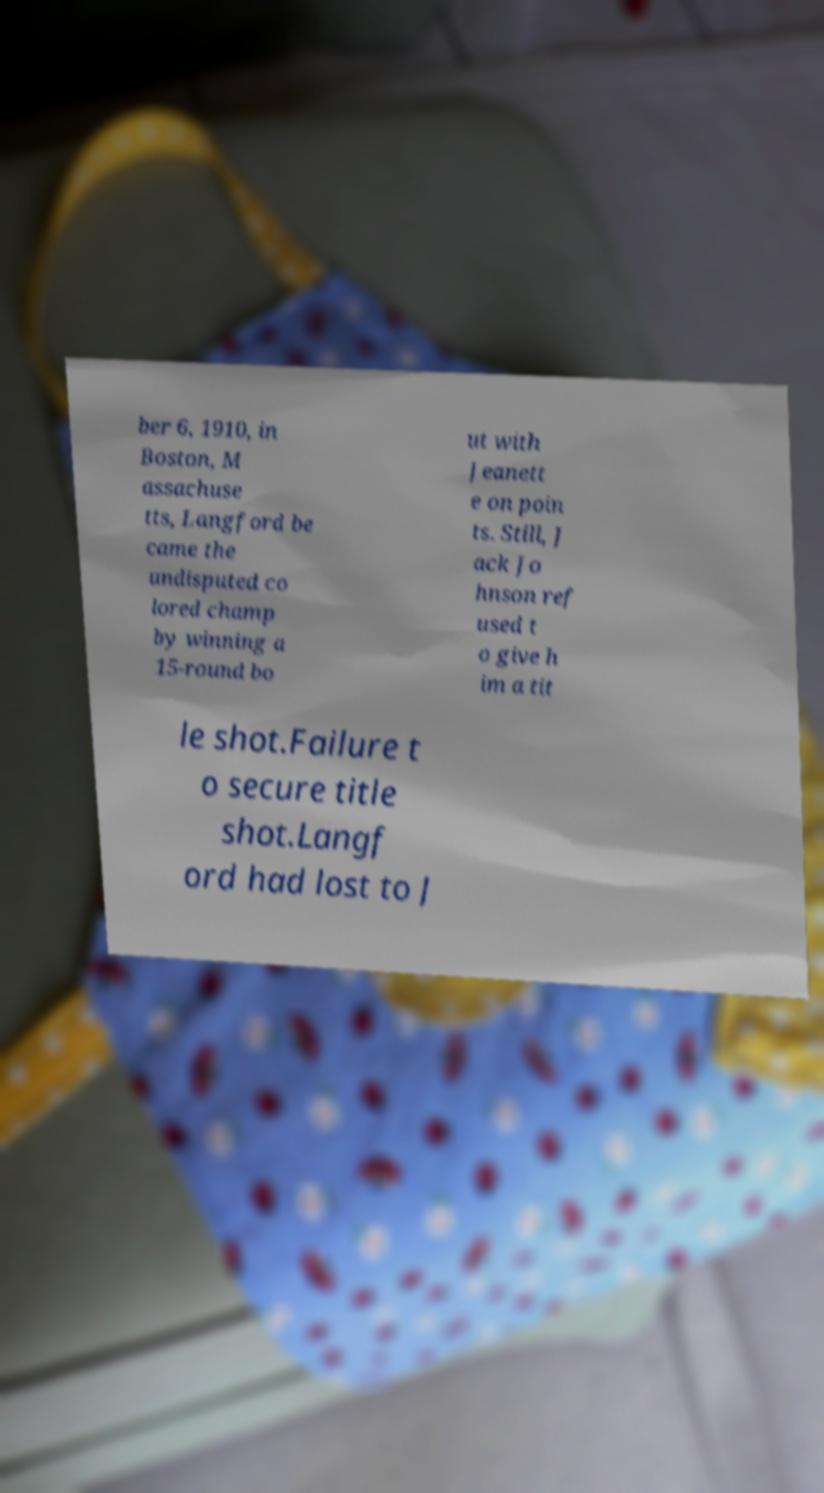Could you extract and type out the text from this image? ber 6, 1910, in Boston, M assachuse tts, Langford be came the undisputed co lored champ by winning a 15-round bo ut with Jeanett e on poin ts. Still, J ack Jo hnson ref used t o give h im a tit le shot.Failure t o secure title shot.Langf ord had lost to J 